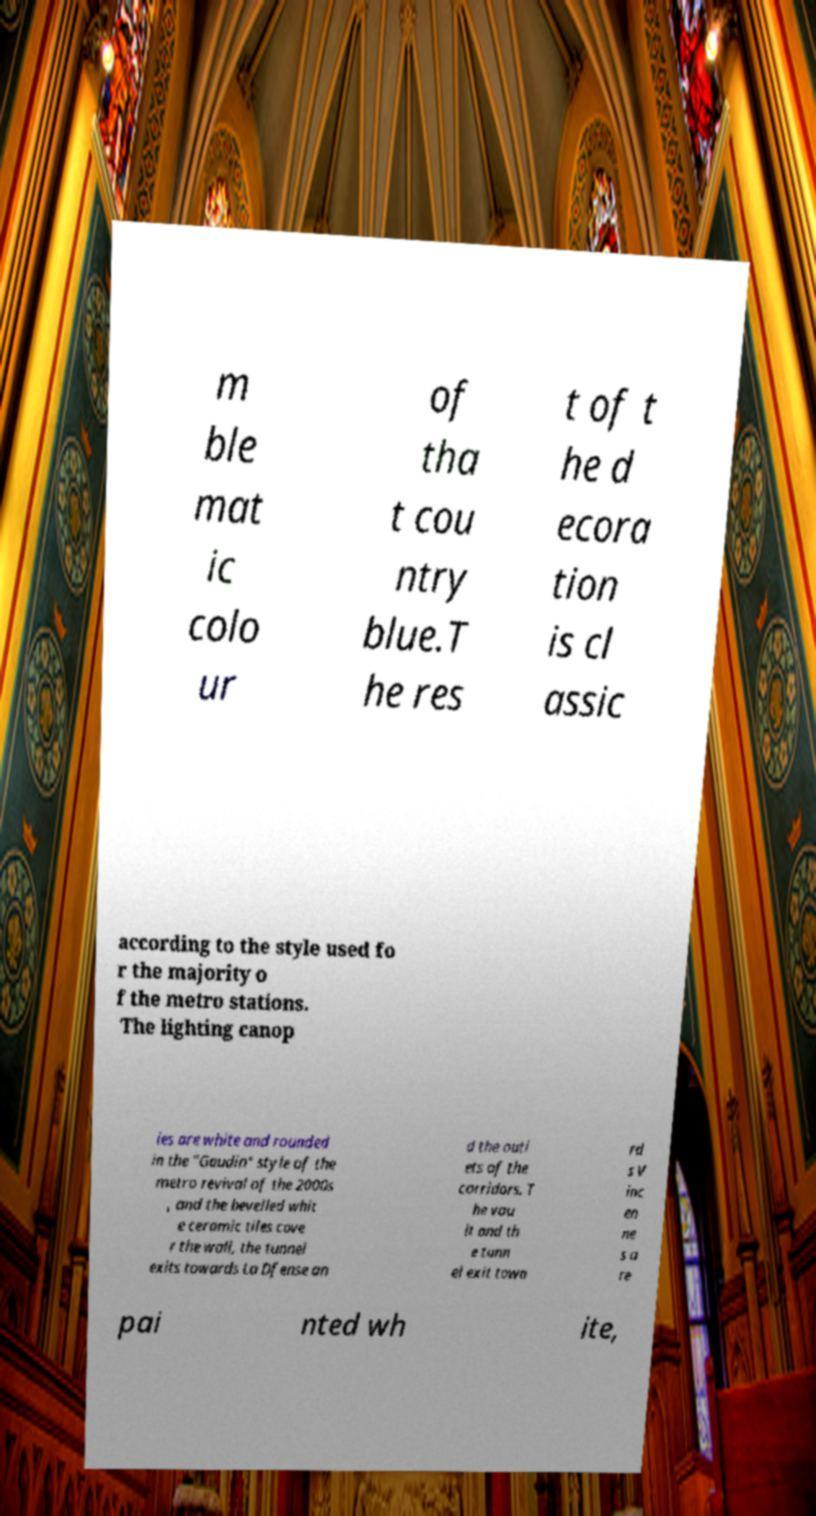Please read and relay the text visible in this image. What does it say? m ble mat ic colo ur of tha t cou ntry blue.T he res t of t he d ecora tion is cl assic according to the style used fo r the majority o f the metro stations. The lighting canop ies are white and rounded in the "Gaudin" style of the metro revival of the 2000s , and the bevelled whit e ceramic tiles cove r the wall, the tunnel exits towards La Dfense an d the outl ets of the corridors. T he vau lt and th e tunn el exit towa rd s V inc en ne s a re pai nted wh ite, 